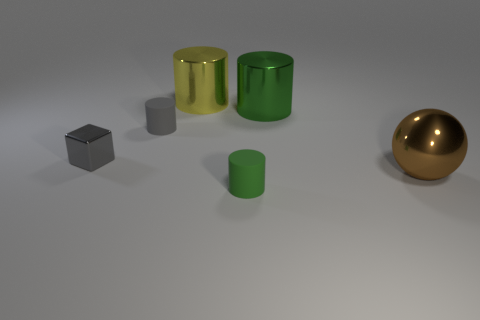Add 2 small rubber things. How many objects exist? 8 Subtract all cubes. How many objects are left? 5 Subtract all large shiny balls. Subtract all big purple balls. How many objects are left? 5 Add 5 small matte objects. How many small matte objects are left? 7 Add 3 large brown metal things. How many large brown metal things exist? 4 Subtract 2 green cylinders. How many objects are left? 4 